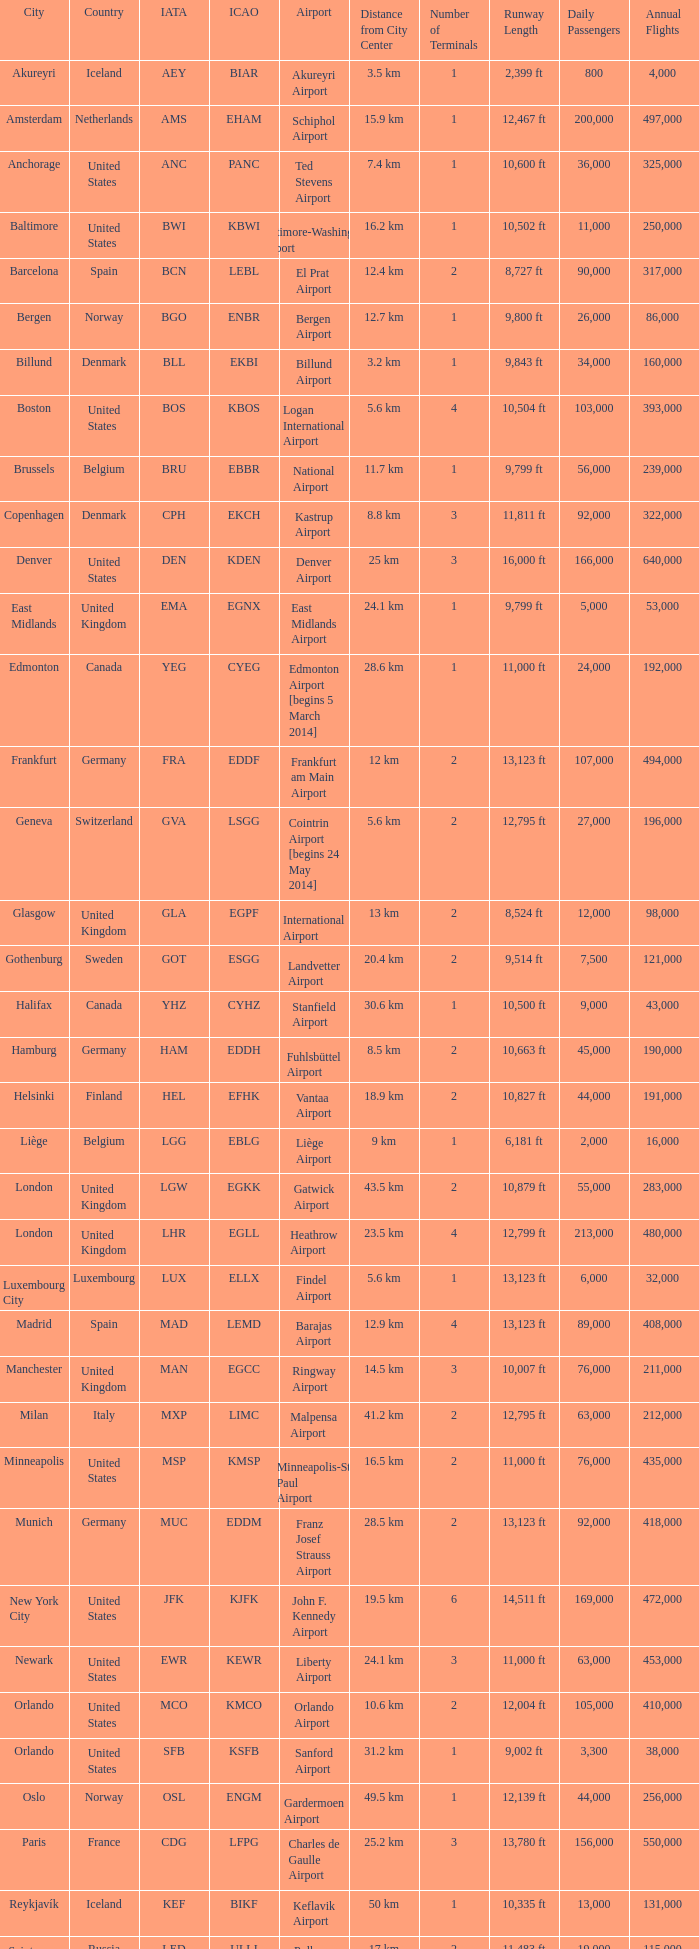In which city can the muc iata code be found? Munich. 